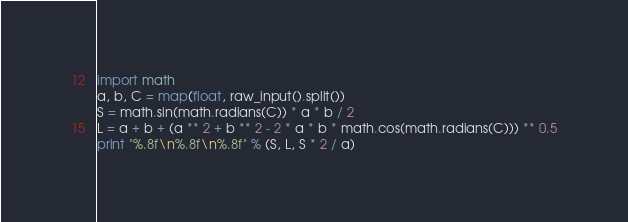<code> <loc_0><loc_0><loc_500><loc_500><_Python_>import math
a, b, C = map(float, raw_input().split())
S = math.sin(math.radians(C)) * a * b / 2
L = a + b + (a ** 2 + b ** 2 - 2 * a * b * math.cos(math.radians(C))) ** 0.5
print "%.8f\n%.8f\n%.8f" % (S, L, S * 2 / a)</code> 